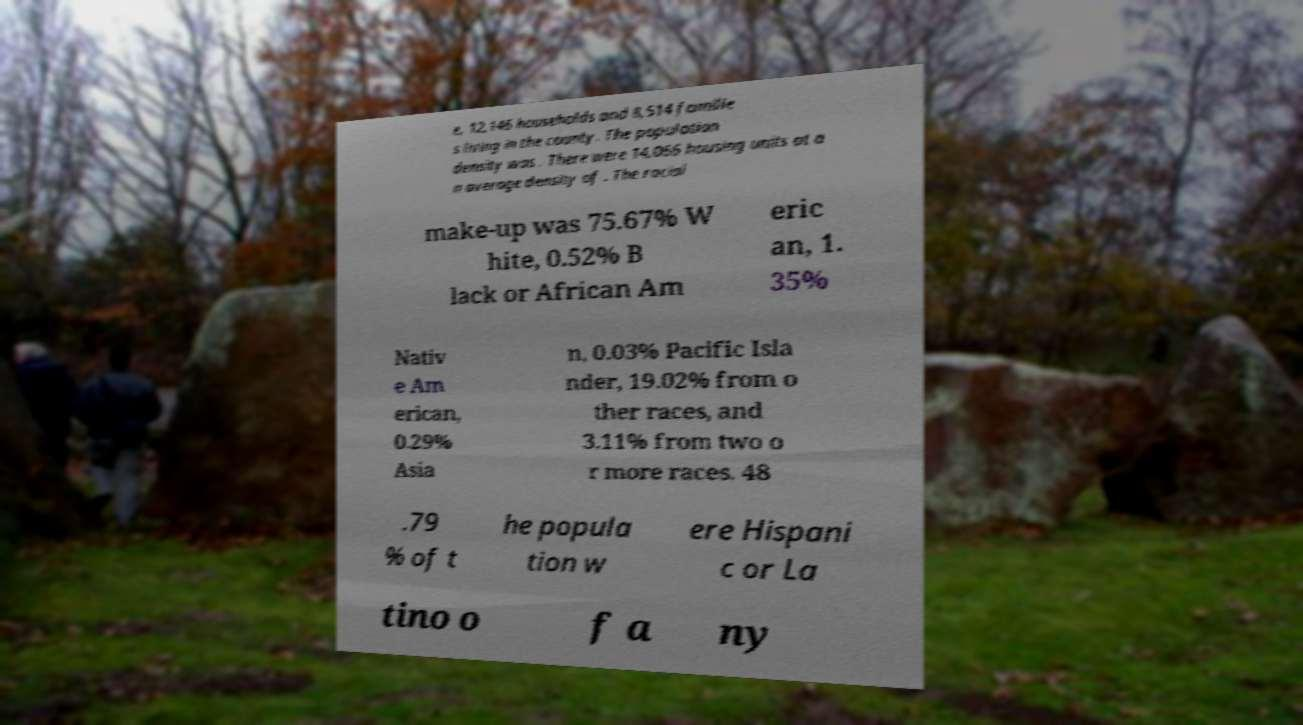Can you read and provide the text displayed in the image?This photo seems to have some interesting text. Can you extract and type it out for me? e, 12,146 households and 8,514 familie s living in the county. The population density was . There were 14,066 housing units at a n average density of . The racial make-up was 75.67% W hite, 0.52% B lack or African Am eric an, 1. 35% Nativ e Am erican, 0.29% Asia n, 0.03% Pacific Isla nder, 19.02% from o ther races, and 3.11% from two o r more races. 48 .79 % of t he popula tion w ere Hispani c or La tino o f a ny 